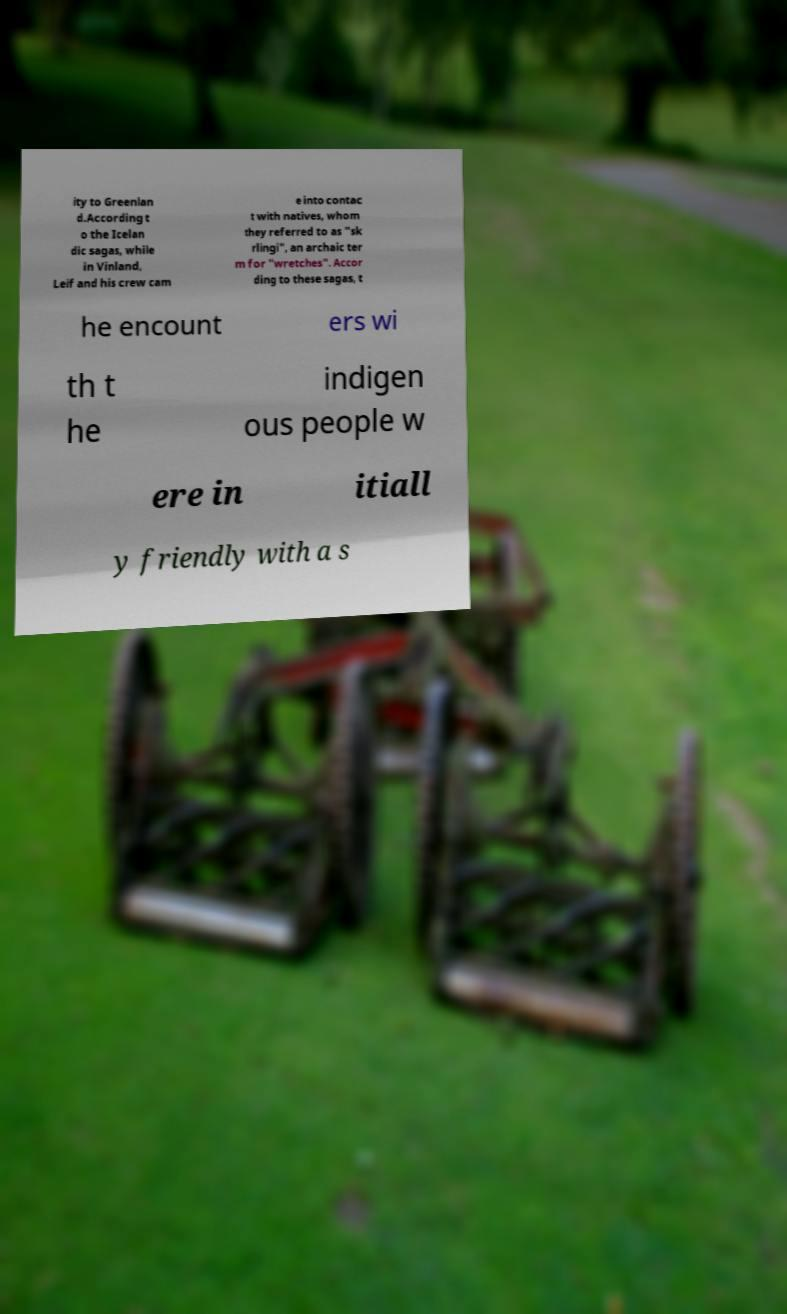Please identify and transcribe the text found in this image. ity to Greenlan d.According t o the Icelan dic sagas, while in Vinland, Leif and his crew cam e into contac t with natives, whom they referred to as "sk rlingi", an archaic ter m for "wretches". Accor ding to these sagas, t he encount ers wi th t he indigen ous people w ere in itiall y friendly with a s 